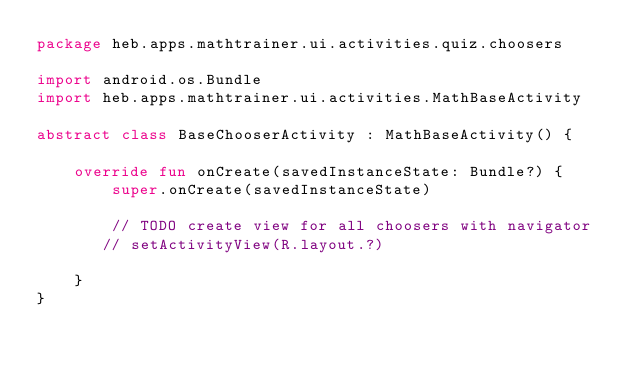Convert code to text. <code><loc_0><loc_0><loc_500><loc_500><_Kotlin_>package heb.apps.mathtrainer.ui.activities.quiz.choosers

import android.os.Bundle
import heb.apps.mathtrainer.ui.activities.MathBaseActivity

abstract class BaseChooserActivity : MathBaseActivity() {

    override fun onCreate(savedInstanceState: Bundle?) {
        super.onCreate(savedInstanceState)

        // TODO create view for all choosers with navigator
       // setActivityView(R.layout.?)

    }
}</code> 